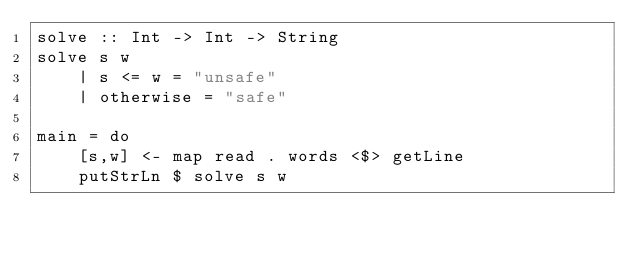<code> <loc_0><loc_0><loc_500><loc_500><_Haskell_>solve :: Int -> Int -> String
solve s w
    | s <= w = "unsafe"
    | otherwise = "safe"

main = do
    [s,w] <- map read . words <$> getLine
    putStrLn $ solve s w</code> 